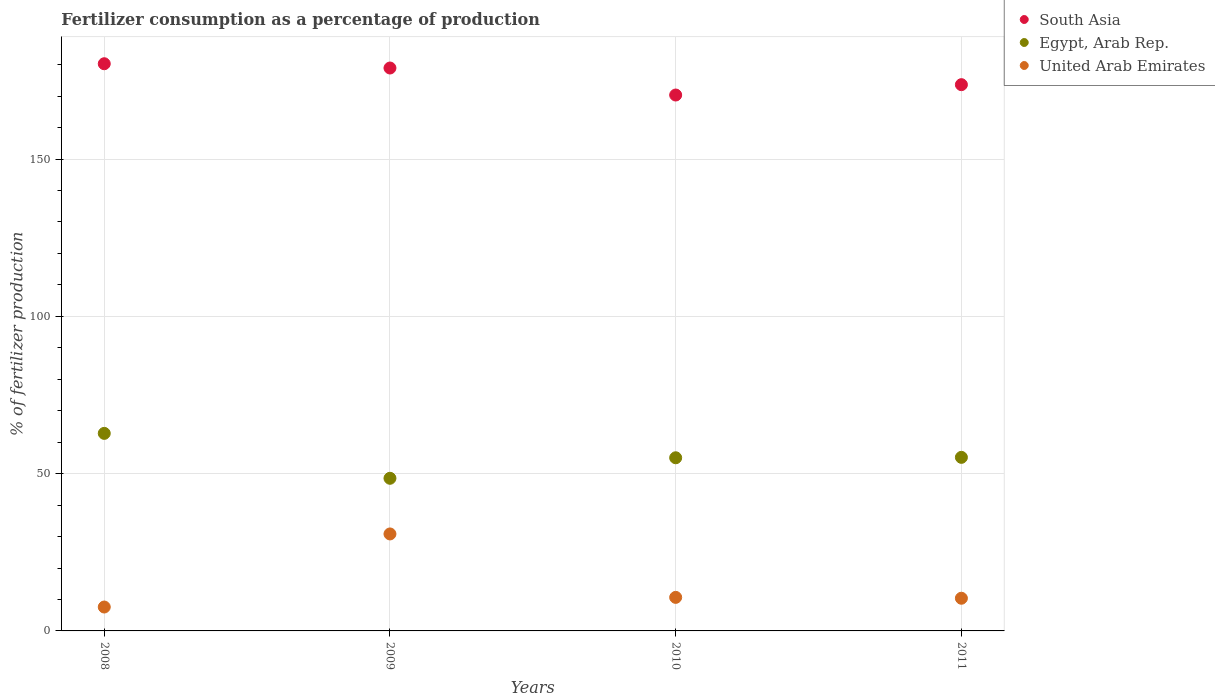Is the number of dotlines equal to the number of legend labels?
Your answer should be very brief. Yes. What is the percentage of fertilizers consumed in Egypt, Arab Rep. in 2011?
Your answer should be compact. 55.18. Across all years, what is the maximum percentage of fertilizers consumed in United Arab Emirates?
Provide a short and direct response. 30.83. Across all years, what is the minimum percentage of fertilizers consumed in South Asia?
Your response must be concise. 170.36. In which year was the percentage of fertilizers consumed in South Asia maximum?
Keep it short and to the point. 2008. In which year was the percentage of fertilizers consumed in United Arab Emirates minimum?
Your answer should be compact. 2008. What is the total percentage of fertilizers consumed in South Asia in the graph?
Ensure brevity in your answer.  703.28. What is the difference between the percentage of fertilizers consumed in United Arab Emirates in 2008 and that in 2009?
Provide a short and direct response. -23.23. What is the difference between the percentage of fertilizers consumed in United Arab Emirates in 2011 and the percentage of fertilizers consumed in South Asia in 2009?
Your response must be concise. -168.56. What is the average percentage of fertilizers consumed in South Asia per year?
Your answer should be very brief. 175.82. In the year 2011, what is the difference between the percentage of fertilizers consumed in United Arab Emirates and percentage of fertilizers consumed in Egypt, Arab Rep.?
Your response must be concise. -44.79. In how many years, is the percentage of fertilizers consumed in Egypt, Arab Rep. greater than 10 %?
Offer a terse response. 4. What is the ratio of the percentage of fertilizers consumed in United Arab Emirates in 2008 to that in 2009?
Provide a succinct answer. 0.25. Is the percentage of fertilizers consumed in Egypt, Arab Rep. in 2008 less than that in 2011?
Ensure brevity in your answer.  No. What is the difference between the highest and the second highest percentage of fertilizers consumed in United Arab Emirates?
Offer a terse response. 20.17. What is the difference between the highest and the lowest percentage of fertilizers consumed in Egypt, Arab Rep.?
Your answer should be very brief. 14.28. Is the sum of the percentage of fertilizers consumed in South Asia in 2010 and 2011 greater than the maximum percentage of fertilizers consumed in United Arab Emirates across all years?
Ensure brevity in your answer.  Yes. How many dotlines are there?
Your response must be concise. 3. What is the difference between two consecutive major ticks on the Y-axis?
Offer a terse response. 50. Does the graph contain any zero values?
Provide a short and direct response. No. Does the graph contain grids?
Provide a short and direct response. Yes. How are the legend labels stacked?
Keep it short and to the point. Vertical. What is the title of the graph?
Offer a very short reply. Fertilizer consumption as a percentage of production. What is the label or title of the X-axis?
Your answer should be compact. Years. What is the label or title of the Y-axis?
Make the answer very short. % of fertilizer production. What is the % of fertilizer production of South Asia in 2008?
Provide a succinct answer. 180.31. What is the % of fertilizer production of Egypt, Arab Rep. in 2008?
Offer a very short reply. 62.8. What is the % of fertilizer production of United Arab Emirates in 2008?
Keep it short and to the point. 7.6. What is the % of fertilizer production of South Asia in 2009?
Provide a succinct answer. 178.95. What is the % of fertilizer production in Egypt, Arab Rep. in 2009?
Keep it short and to the point. 48.52. What is the % of fertilizer production in United Arab Emirates in 2009?
Your response must be concise. 30.83. What is the % of fertilizer production in South Asia in 2010?
Your answer should be compact. 170.36. What is the % of fertilizer production in Egypt, Arab Rep. in 2010?
Keep it short and to the point. 55.04. What is the % of fertilizer production in United Arab Emirates in 2010?
Provide a succinct answer. 10.66. What is the % of fertilizer production of South Asia in 2011?
Provide a succinct answer. 173.66. What is the % of fertilizer production in Egypt, Arab Rep. in 2011?
Keep it short and to the point. 55.18. What is the % of fertilizer production of United Arab Emirates in 2011?
Your answer should be very brief. 10.39. Across all years, what is the maximum % of fertilizer production in South Asia?
Your answer should be compact. 180.31. Across all years, what is the maximum % of fertilizer production in Egypt, Arab Rep.?
Offer a terse response. 62.8. Across all years, what is the maximum % of fertilizer production of United Arab Emirates?
Offer a terse response. 30.83. Across all years, what is the minimum % of fertilizer production in South Asia?
Your response must be concise. 170.36. Across all years, what is the minimum % of fertilizer production in Egypt, Arab Rep.?
Your answer should be compact. 48.52. Across all years, what is the minimum % of fertilizer production in United Arab Emirates?
Provide a short and direct response. 7.6. What is the total % of fertilizer production of South Asia in the graph?
Provide a short and direct response. 703.28. What is the total % of fertilizer production of Egypt, Arab Rep. in the graph?
Offer a very short reply. 221.54. What is the total % of fertilizer production in United Arab Emirates in the graph?
Provide a short and direct response. 59.48. What is the difference between the % of fertilizer production in South Asia in 2008 and that in 2009?
Ensure brevity in your answer.  1.36. What is the difference between the % of fertilizer production of Egypt, Arab Rep. in 2008 and that in 2009?
Make the answer very short. 14.28. What is the difference between the % of fertilizer production in United Arab Emirates in 2008 and that in 2009?
Make the answer very short. -23.23. What is the difference between the % of fertilizer production in South Asia in 2008 and that in 2010?
Ensure brevity in your answer.  9.94. What is the difference between the % of fertilizer production in Egypt, Arab Rep. in 2008 and that in 2010?
Offer a very short reply. 7.76. What is the difference between the % of fertilizer production in United Arab Emirates in 2008 and that in 2010?
Provide a short and direct response. -3.07. What is the difference between the % of fertilizer production in South Asia in 2008 and that in 2011?
Offer a terse response. 6.65. What is the difference between the % of fertilizer production of Egypt, Arab Rep. in 2008 and that in 2011?
Make the answer very short. 7.62. What is the difference between the % of fertilizer production in United Arab Emirates in 2008 and that in 2011?
Your answer should be compact. -2.79. What is the difference between the % of fertilizer production in South Asia in 2009 and that in 2010?
Offer a terse response. 8.59. What is the difference between the % of fertilizer production of Egypt, Arab Rep. in 2009 and that in 2010?
Provide a succinct answer. -6.52. What is the difference between the % of fertilizer production in United Arab Emirates in 2009 and that in 2010?
Offer a very short reply. 20.17. What is the difference between the % of fertilizer production of South Asia in 2009 and that in 2011?
Provide a short and direct response. 5.29. What is the difference between the % of fertilizer production in Egypt, Arab Rep. in 2009 and that in 2011?
Keep it short and to the point. -6.66. What is the difference between the % of fertilizer production of United Arab Emirates in 2009 and that in 2011?
Keep it short and to the point. 20.44. What is the difference between the % of fertilizer production in South Asia in 2010 and that in 2011?
Keep it short and to the point. -3.29. What is the difference between the % of fertilizer production in Egypt, Arab Rep. in 2010 and that in 2011?
Provide a short and direct response. -0.14. What is the difference between the % of fertilizer production of United Arab Emirates in 2010 and that in 2011?
Your response must be concise. 0.28. What is the difference between the % of fertilizer production of South Asia in 2008 and the % of fertilizer production of Egypt, Arab Rep. in 2009?
Ensure brevity in your answer.  131.79. What is the difference between the % of fertilizer production in South Asia in 2008 and the % of fertilizer production in United Arab Emirates in 2009?
Ensure brevity in your answer.  149.48. What is the difference between the % of fertilizer production in Egypt, Arab Rep. in 2008 and the % of fertilizer production in United Arab Emirates in 2009?
Your answer should be compact. 31.97. What is the difference between the % of fertilizer production in South Asia in 2008 and the % of fertilizer production in Egypt, Arab Rep. in 2010?
Provide a short and direct response. 125.27. What is the difference between the % of fertilizer production of South Asia in 2008 and the % of fertilizer production of United Arab Emirates in 2010?
Provide a short and direct response. 169.64. What is the difference between the % of fertilizer production in Egypt, Arab Rep. in 2008 and the % of fertilizer production in United Arab Emirates in 2010?
Your answer should be very brief. 52.13. What is the difference between the % of fertilizer production of South Asia in 2008 and the % of fertilizer production of Egypt, Arab Rep. in 2011?
Offer a very short reply. 125.13. What is the difference between the % of fertilizer production of South Asia in 2008 and the % of fertilizer production of United Arab Emirates in 2011?
Your response must be concise. 169.92. What is the difference between the % of fertilizer production in Egypt, Arab Rep. in 2008 and the % of fertilizer production in United Arab Emirates in 2011?
Your response must be concise. 52.41. What is the difference between the % of fertilizer production of South Asia in 2009 and the % of fertilizer production of Egypt, Arab Rep. in 2010?
Give a very brief answer. 123.91. What is the difference between the % of fertilizer production in South Asia in 2009 and the % of fertilizer production in United Arab Emirates in 2010?
Give a very brief answer. 168.29. What is the difference between the % of fertilizer production of Egypt, Arab Rep. in 2009 and the % of fertilizer production of United Arab Emirates in 2010?
Keep it short and to the point. 37.86. What is the difference between the % of fertilizer production of South Asia in 2009 and the % of fertilizer production of Egypt, Arab Rep. in 2011?
Provide a short and direct response. 123.77. What is the difference between the % of fertilizer production of South Asia in 2009 and the % of fertilizer production of United Arab Emirates in 2011?
Your response must be concise. 168.56. What is the difference between the % of fertilizer production in Egypt, Arab Rep. in 2009 and the % of fertilizer production in United Arab Emirates in 2011?
Keep it short and to the point. 38.14. What is the difference between the % of fertilizer production of South Asia in 2010 and the % of fertilizer production of Egypt, Arab Rep. in 2011?
Your answer should be very brief. 115.19. What is the difference between the % of fertilizer production in South Asia in 2010 and the % of fertilizer production in United Arab Emirates in 2011?
Offer a very short reply. 159.98. What is the difference between the % of fertilizer production in Egypt, Arab Rep. in 2010 and the % of fertilizer production in United Arab Emirates in 2011?
Provide a succinct answer. 44.66. What is the average % of fertilizer production in South Asia per year?
Your response must be concise. 175.82. What is the average % of fertilizer production in Egypt, Arab Rep. per year?
Make the answer very short. 55.39. What is the average % of fertilizer production in United Arab Emirates per year?
Ensure brevity in your answer.  14.87. In the year 2008, what is the difference between the % of fertilizer production in South Asia and % of fertilizer production in Egypt, Arab Rep.?
Offer a very short reply. 117.51. In the year 2008, what is the difference between the % of fertilizer production in South Asia and % of fertilizer production in United Arab Emirates?
Your response must be concise. 172.71. In the year 2008, what is the difference between the % of fertilizer production in Egypt, Arab Rep. and % of fertilizer production in United Arab Emirates?
Your answer should be compact. 55.2. In the year 2009, what is the difference between the % of fertilizer production in South Asia and % of fertilizer production in Egypt, Arab Rep.?
Offer a very short reply. 130.43. In the year 2009, what is the difference between the % of fertilizer production of South Asia and % of fertilizer production of United Arab Emirates?
Give a very brief answer. 148.12. In the year 2009, what is the difference between the % of fertilizer production in Egypt, Arab Rep. and % of fertilizer production in United Arab Emirates?
Keep it short and to the point. 17.69. In the year 2010, what is the difference between the % of fertilizer production in South Asia and % of fertilizer production in Egypt, Arab Rep.?
Your response must be concise. 115.32. In the year 2010, what is the difference between the % of fertilizer production of South Asia and % of fertilizer production of United Arab Emirates?
Ensure brevity in your answer.  159.7. In the year 2010, what is the difference between the % of fertilizer production of Egypt, Arab Rep. and % of fertilizer production of United Arab Emirates?
Give a very brief answer. 44.38. In the year 2011, what is the difference between the % of fertilizer production in South Asia and % of fertilizer production in Egypt, Arab Rep.?
Keep it short and to the point. 118.48. In the year 2011, what is the difference between the % of fertilizer production in South Asia and % of fertilizer production in United Arab Emirates?
Your answer should be compact. 163.27. In the year 2011, what is the difference between the % of fertilizer production in Egypt, Arab Rep. and % of fertilizer production in United Arab Emirates?
Keep it short and to the point. 44.79. What is the ratio of the % of fertilizer production in South Asia in 2008 to that in 2009?
Give a very brief answer. 1.01. What is the ratio of the % of fertilizer production of Egypt, Arab Rep. in 2008 to that in 2009?
Ensure brevity in your answer.  1.29. What is the ratio of the % of fertilizer production of United Arab Emirates in 2008 to that in 2009?
Offer a terse response. 0.25. What is the ratio of the % of fertilizer production of South Asia in 2008 to that in 2010?
Your answer should be compact. 1.06. What is the ratio of the % of fertilizer production in Egypt, Arab Rep. in 2008 to that in 2010?
Your response must be concise. 1.14. What is the ratio of the % of fertilizer production in United Arab Emirates in 2008 to that in 2010?
Offer a terse response. 0.71. What is the ratio of the % of fertilizer production of South Asia in 2008 to that in 2011?
Make the answer very short. 1.04. What is the ratio of the % of fertilizer production in Egypt, Arab Rep. in 2008 to that in 2011?
Your answer should be compact. 1.14. What is the ratio of the % of fertilizer production in United Arab Emirates in 2008 to that in 2011?
Ensure brevity in your answer.  0.73. What is the ratio of the % of fertilizer production of South Asia in 2009 to that in 2010?
Offer a terse response. 1.05. What is the ratio of the % of fertilizer production in Egypt, Arab Rep. in 2009 to that in 2010?
Provide a succinct answer. 0.88. What is the ratio of the % of fertilizer production in United Arab Emirates in 2009 to that in 2010?
Keep it short and to the point. 2.89. What is the ratio of the % of fertilizer production of South Asia in 2009 to that in 2011?
Offer a very short reply. 1.03. What is the ratio of the % of fertilizer production in Egypt, Arab Rep. in 2009 to that in 2011?
Provide a succinct answer. 0.88. What is the ratio of the % of fertilizer production of United Arab Emirates in 2009 to that in 2011?
Your answer should be very brief. 2.97. What is the ratio of the % of fertilizer production of South Asia in 2010 to that in 2011?
Give a very brief answer. 0.98. What is the ratio of the % of fertilizer production of Egypt, Arab Rep. in 2010 to that in 2011?
Make the answer very short. 1. What is the ratio of the % of fertilizer production in United Arab Emirates in 2010 to that in 2011?
Provide a short and direct response. 1.03. What is the difference between the highest and the second highest % of fertilizer production of South Asia?
Offer a very short reply. 1.36. What is the difference between the highest and the second highest % of fertilizer production in Egypt, Arab Rep.?
Provide a short and direct response. 7.62. What is the difference between the highest and the second highest % of fertilizer production of United Arab Emirates?
Your answer should be compact. 20.17. What is the difference between the highest and the lowest % of fertilizer production of South Asia?
Provide a succinct answer. 9.94. What is the difference between the highest and the lowest % of fertilizer production of Egypt, Arab Rep.?
Provide a short and direct response. 14.28. What is the difference between the highest and the lowest % of fertilizer production of United Arab Emirates?
Keep it short and to the point. 23.23. 